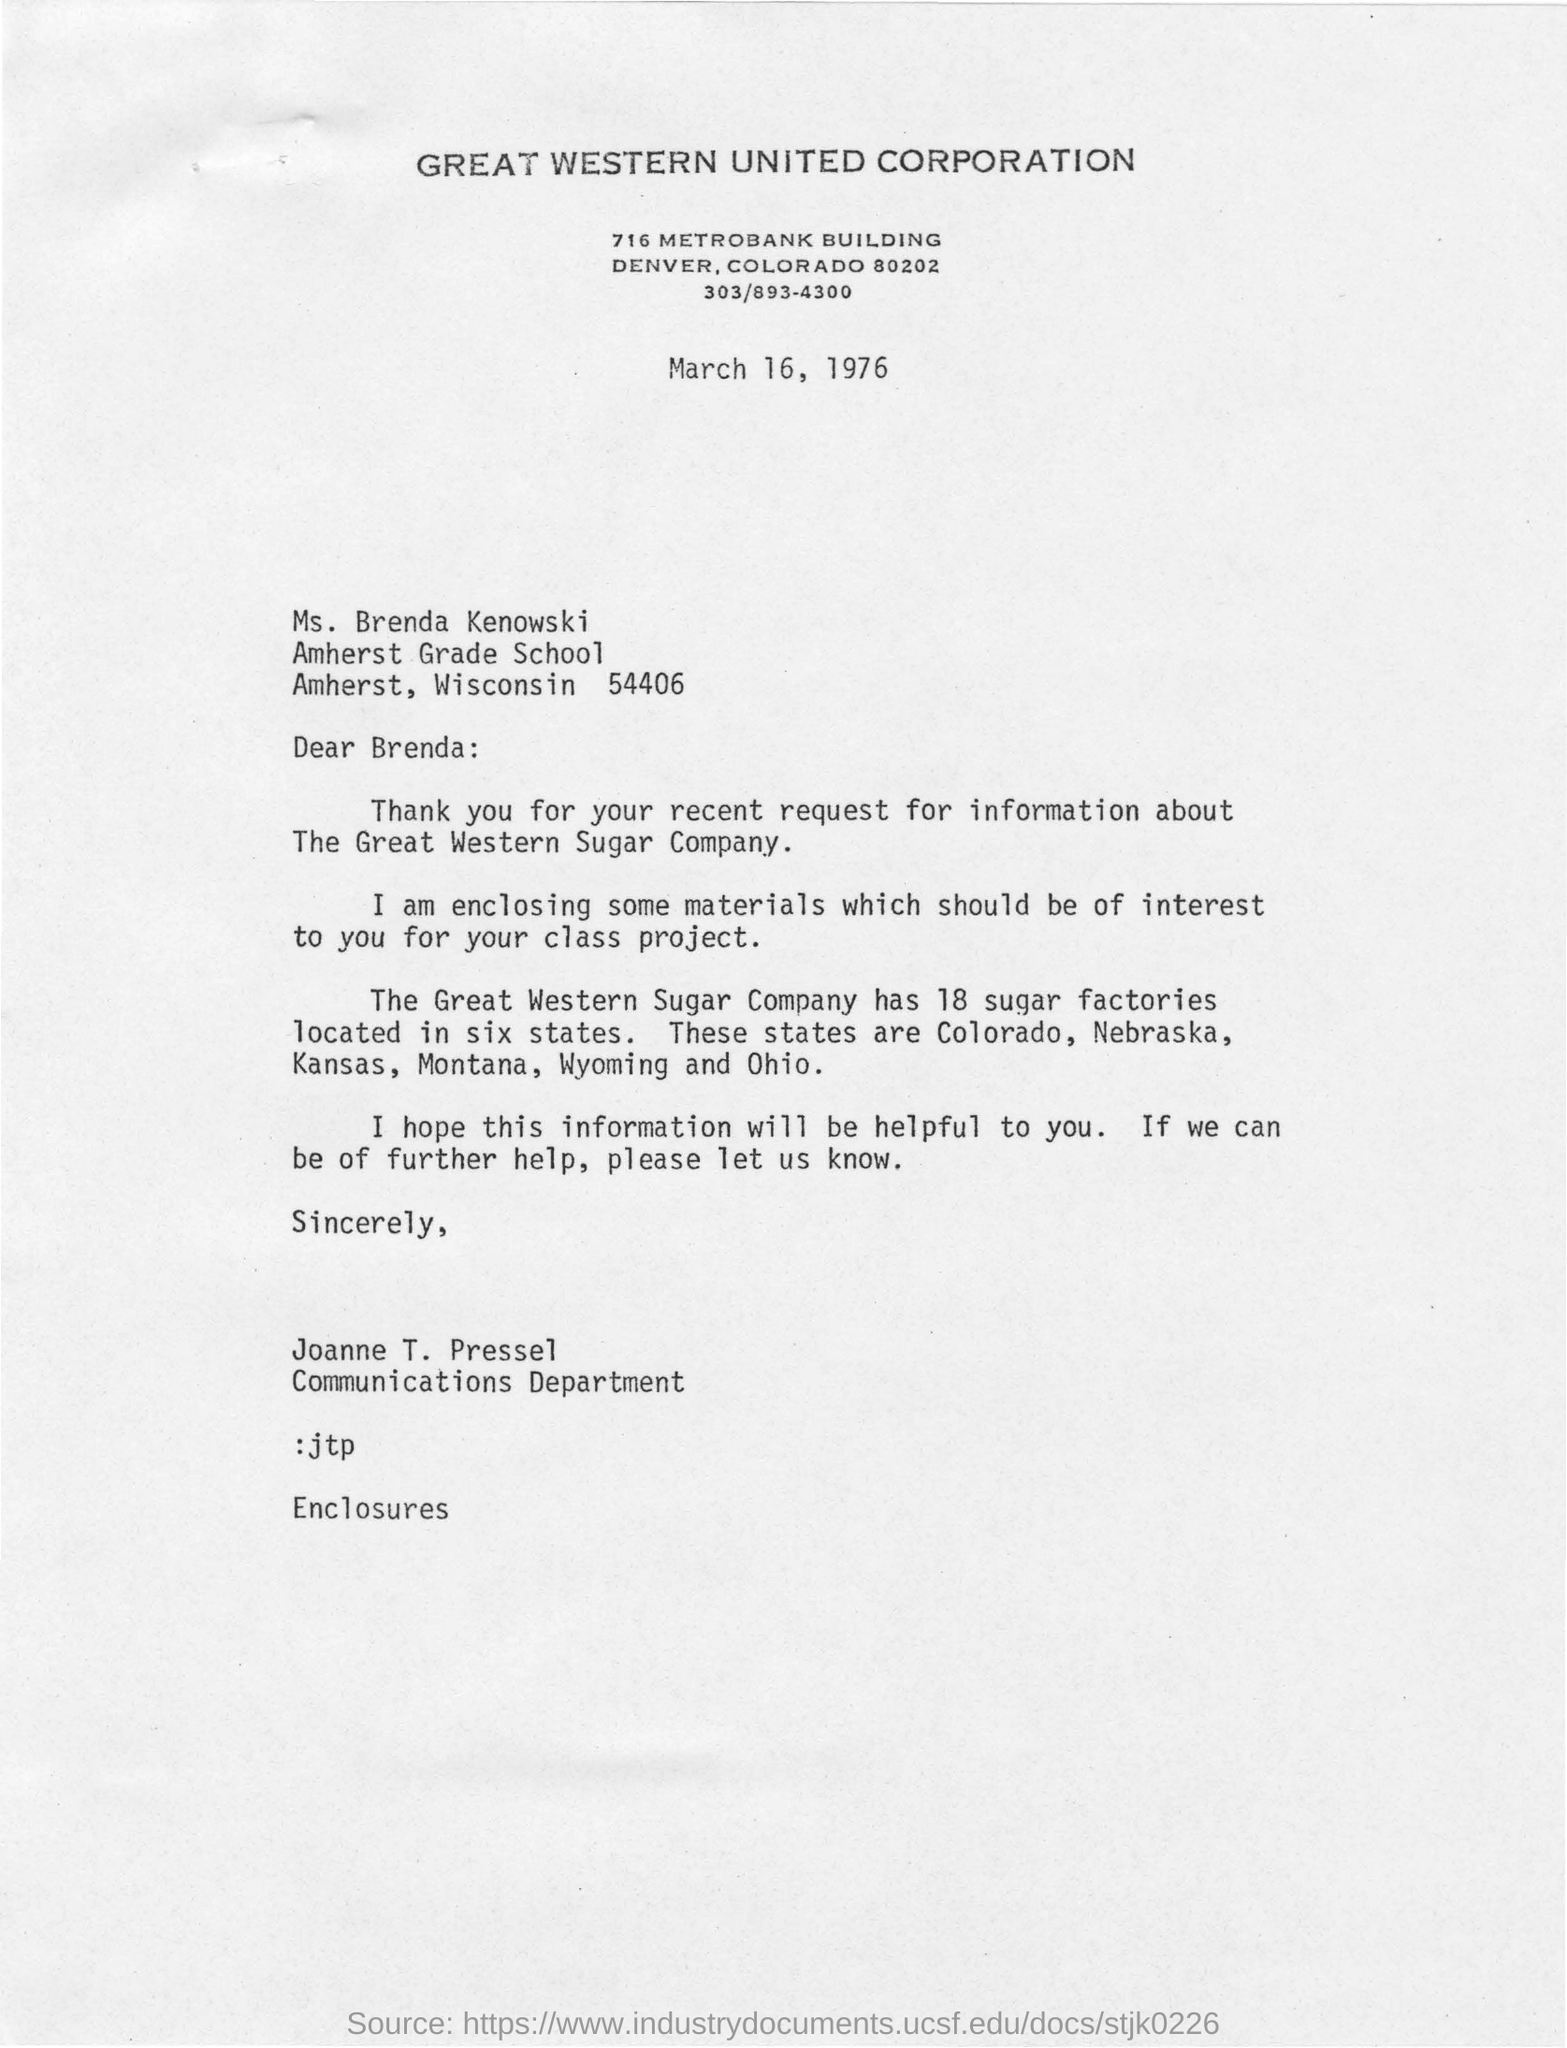List a handful of essential elements in this visual. Great Western United Corporation is the name of the corporation. Joanne T. Pressel is a member of the Communications Department. Six states are part of the Great Western Sugar Company, and there are a total of 18 sugar factories located within these states. The recent request seeks information about the Great Western Sugar Company. The letter was written to Brenda. 